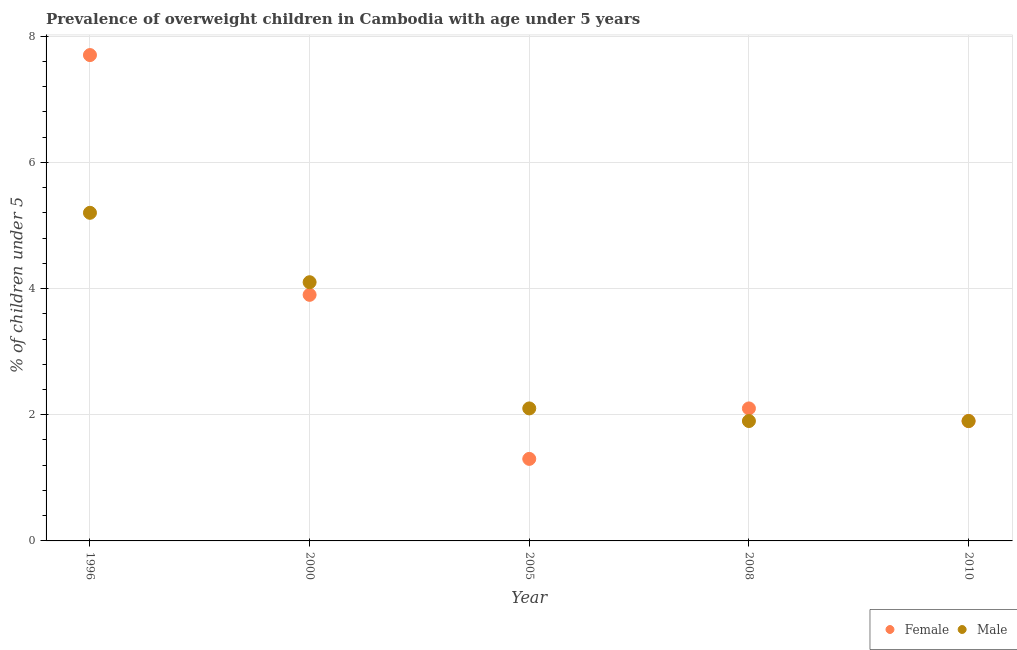How many different coloured dotlines are there?
Your answer should be compact. 2. What is the percentage of obese female children in 2010?
Give a very brief answer. 1.9. Across all years, what is the maximum percentage of obese male children?
Provide a short and direct response. 5.2. Across all years, what is the minimum percentage of obese female children?
Make the answer very short. 1.3. What is the total percentage of obese female children in the graph?
Keep it short and to the point. 16.9. What is the difference between the percentage of obese male children in 1996 and that in 2010?
Keep it short and to the point. 3.3. What is the difference between the percentage of obese female children in 1996 and the percentage of obese male children in 2005?
Make the answer very short. 5.6. What is the average percentage of obese male children per year?
Give a very brief answer. 3.04. In the year 2008, what is the difference between the percentage of obese male children and percentage of obese female children?
Provide a short and direct response. -0.2. In how many years, is the percentage of obese female children greater than 0.8 %?
Make the answer very short. 5. What is the ratio of the percentage of obese male children in 2000 to that in 2008?
Offer a very short reply. 2.16. Is the percentage of obese male children in 2000 less than that in 2008?
Give a very brief answer. No. Is the difference between the percentage of obese female children in 2000 and 2005 greater than the difference between the percentage of obese male children in 2000 and 2005?
Ensure brevity in your answer.  Yes. What is the difference between the highest and the second highest percentage of obese male children?
Ensure brevity in your answer.  1.1. What is the difference between the highest and the lowest percentage of obese female children?
Make the answer very short. 6.4. In how many years, is the percentage of obese female children greater than the average percentage of obese female children taken over all years?
Provide a short and direct response. 2. Is the percentage of obese female children strictly less than the percentage of obese male children over the years?
Make the answer very short. No. Does the graph contain any zero values?
Give a very brief answer. No. Does the graph contain grids?
Give a very brief answer. Yes. What is the title of the graph?
Offer a terse response. Prevalence of overweight children in Cambodia with age under 5 years. Does "IMF nonconcessional" appear as one of the legend labels in the graph?
Your answer should be very brief. No. What is the label or title of the X-axis?
Make the answer very short. Year. What is the label or title of the Y-axis?
Make the answer very short.  % of children under 5. What is the  % of children under 5 of Female in 1996?
Make the answer very short. 7.7. What is the  % of children under 5 in Male in 1996?
Offer a very short reply. 5.2. What is the  % of children under 5 of Female in 2000?
Your answer should be very brief. 3.9. What is the  % of children under 5 in Male in 2000?
Provide a short and direct response. 4.1. What is the  % of children under 5 in Female in 2005?
Your answer should be very brief. 1.3. What is the  % of children under 5 of Male in 2005?
Make the answer very short. 2.1. What is the  % of children under 5 of Female in 2008?
Ensure brevity in your answer.  2.1. What is the  % of children under 5 of Male in 2008?
Your answer should be compact. 1.9. What is the  % of children under 5 in Female in 2010?
Your answer should be compact. 1.9. What is the  % of children under 5 of Male in 2010?
Give a very brief answer. 1.9. Across all years, what is the maximum  % of children under 5 of Female?
Your response must be concise. 7.7. Across all years, what is the maximum  % of children under 5 in Male?
Keep it short and to the point. 5.2. Across all years, what is the minimum  % of children under 5 in Female?
Ensure brevity in your answer.  1.3. Across all years, what is the minimum  % of children under 5 in Male?
Your answer should be very brief. 1.9. What is the total  % of children under 5 in Female in the graph?
Keep it short and to the point. 16.9. What is the total  % of children under 5 of Male in the graph?
Your answer should be very brief. 15.2. What is the difference between the  % of children under 5 of Female in 1996 and that in 2005?
Make the answer very short. 6.4. What is the difference between the  % of children under 5 of Female in 1996 and that in 2010?
Provide a short and direct response. 5.8. What is the difference between the  % of children under 5 of Male in 2000 and that in 2005?
Your response must be concise. 2. What is the difference between the  % of children under 5 of Female in 2000 and that in 2008?
Keep it short and to the point. 1.8. What is the difference between the  % of children under 5 of Male in 2000 and that in 2010?
Give a very brief answer. 2.2. What is the difference between the  % of children under 5 in Male in 2005 and that in 2008?
Your response must be concise. 0.2. What is the difference between the  % of children under 5 in Female in 2005 and that in 2010?
Your answer should be very brief. -0.6. What is the difference between the  % of children under 5 in Female in 1996 and the  % of children under 5 in Male in 2000?
Ensure brevity in your answer.  3.6. What is the difference between the  % of children under 5 in Female in 1996 and the  % of children under 5 in Male in 2005?
Offer a very short reply. 5.6. What is the difference between the  % of children under 5 of Female in 1996 and the  % of children under 5 of Male in 2008?
Your response must be concise. 5.8. What is the difference between the  % of children under 5 of Female in 2000 and the  % of children under 5 of Male in 2008?
Provide a succinct answer. 2. What is the difference between the  % of children under 5 of Female in 2005 and the  % of children under 5 of Male in 2008?
Make the answer very short. -0.6. What is the difference between the  % of children under 5 in Female in 2005 and the  % of children under 5 in Male in 2010?
Keep it short and to the point. -0.6. What is the difference between the  % of children under 5 of Female in 2008 and the  % of children under 5 of Male in 2010?
Your answer should be compact. 0.2. What is the average  % of children under 5 in Female per year?
Your response must be concise. 3.38. What is the average  % of children under 5 in Male per year?
Provide a succinct answer. 3.04. In the year 1996, what is the difference between the  % of children under 5 in Female and  % of children under 5 in Male?
Your answer should be compact. 2.5. In the year 2005, what is the difference between the  % of children under 5 in Female and  % of children under 5 in Male?
Offer a terse response. -0.8. In the year 2008, what is the difference between the  % of children under 5 in Female and  % of children under 5 in Male?
Provide a succinct answer. 0.2. What is the ratio of the  % of children under 5 of Female in 1996 to that in 2000?
Provide a short and direct response. 1.97. What is the ratio of the  % of children under 5 of Male in 1996 to that in 2000?
Provide a succinct answer. 1.27. What is the ratio of the  % of children under 5 in Female in 1996 to that in 2005?
Provide a succinct answer. 5.92. What is the ratio of the  % of children under 5 in Male in 1996 to that in 2005?
Offer a terse response. 2.48. What is the ratio of the  % of children under 5 of Female in 1996 to that in 2008?
Your answer should be very brief. 3.67. What is the ratio of the  % of children under 5 of Male in 1996 to that in 2008?
Offer a terse response. 2.74. What is the ratio of the  % of children under 5 in Female in 1996 to that in 2010?
Provide a short and direct response. 4.05. What is the ratio of the  % of children under 5 in Male in 1996 to that in 2010?
Keep it short and to the point. 2.74. What is the ratio of the  % of children under 5 of Male in 2000 to that in 2005?
Make the answer very short. 1.95. What is the ratio of the  % of children under 5 in Female in 2000 to that in 2008?
Keep it short and to the point. 1.86. What is the ratio of the  % of children under 5 in Male in 2000 to that in 2008?
Your answer should be compact. 2.16. What is the ratio of the  % of children under 5 of Female in 2000 to that in 2010?
Your answer should be compact. 2.05. What is the ratio of the  % of children under 5 in Male in 2000 to that in 2010?
Make the answer very short. 2.16. What is the ratio of the  % of children under 5 in Female in 2005 to that in 2008?
Keep it short and to the point. 0.62. What is the ratio of the  % of children under 5 in Male in 2005 to that in 2008?
Ensure brevity in your answer.  1.11. What is the ratio of the  % of children under 5 in Female in 2005 to that in 2010?
Ensure brevity in your answer.  0.68. What is the ratio of the  % of children under 5 in Male in 2005 to that in 2010?
Your response must be concise. 1.11. What is the ratio of the  % of children under 5 in Female in 2008 to that in 2010?
Make the answer very short. 1.11. What is the ratio of the  % of children under 5 in Male in 2008 to that in 2010?
Your answer should be very brief. 1. What is the difference between the highest and the second highest  % of children under 5 in Female?
Keep it short and to the point. 3.8. What is the difference between the highest and the lowest  % of children under 5 in Female?
Ensure brevity in your answer.  6.4. 